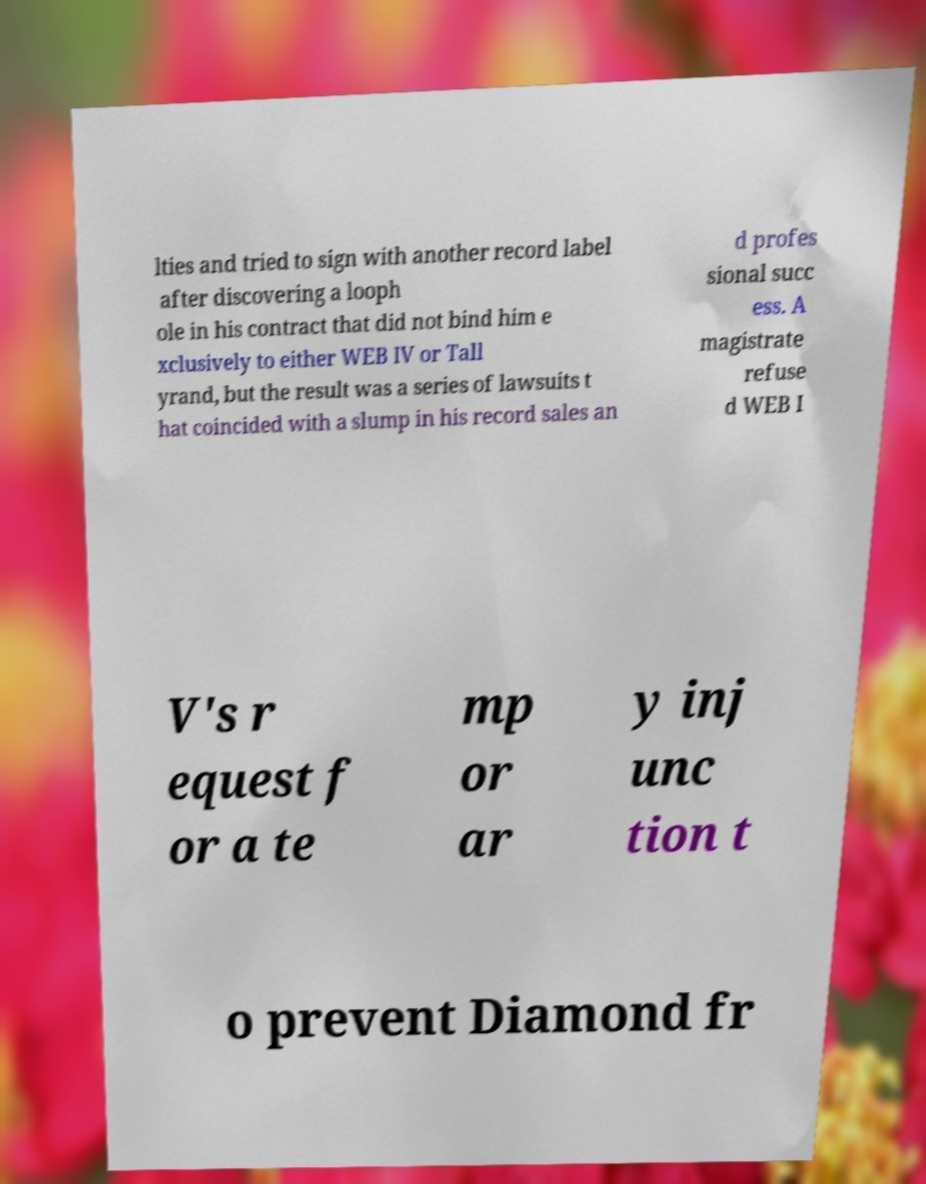Please read and relay the text visible in this image. What does it say? lties and tried to sign with another record label after discovering a looph ole in his contract that did not bind him e xclusively to either WEB IV or Tall yrand, but the result was a series of lawsuits t hat coincided with a slump in his record sales an d profes sional succ ess. A magistrate refuse d WEB I V's r equest f or a te mp or ar y inj unc tion t o prevent Diamond fr 